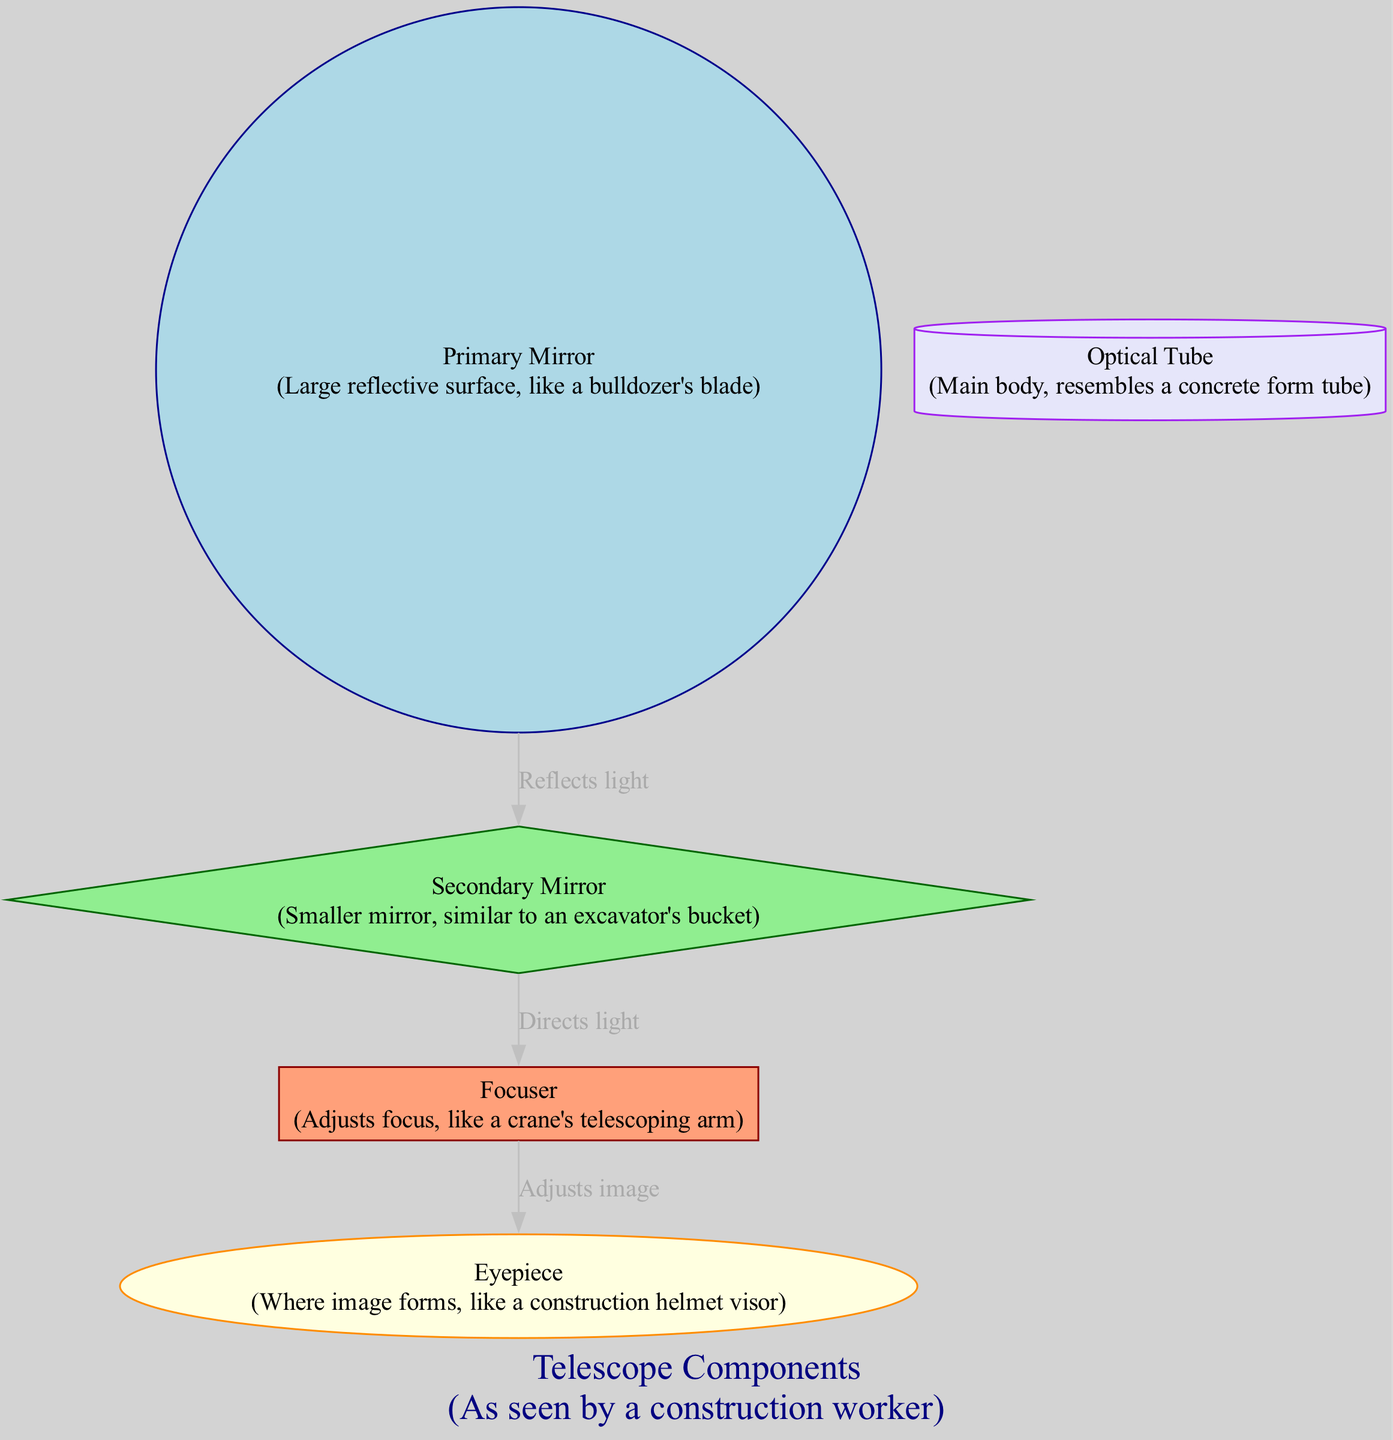What is the main reflective surface of the telescope? The diagram identifies the "Primary Mirror" as the large reflective surface, analogous to a bulldozer's blade. This is a labeled component that highlights its role and resemblance to construction equipment.
Answer: Primary Mirror How many components are shown in the diagram? By counting the nodes listed in the diagram, there are five identified components: Primary Mirror, Secondary Mirror, Focuser, Eyepiece, and Optical Tube. This count includes all distinct parts represented.
Answer: 5 What does the Secondary Mirror do? The Secondary Mirror reflects light towards the Focuser, as indicated by the connecting edge labeled "Directs light." This shows its functional role in the light path of the telescope.
Answer: Directs light What shapes are used for the Focuser and Eyepiece? The diagram specifies the shapes used for these components: the Focuser is a rectangle, and the Eyepiece is an oval. These descriptions of shape differentiate the components visually in the context of construction forms.
Answer: Rectangle, Oval Which component is responsible for adjusting the focus of the image? The Focuser is designated as the component that adjusts the focus, indicated clearly in the diagram's flow and described with its analogy to a crane's telescoping arm.
Answer: Focuser What is the connection between the Primary Mirror and Secondary Mirror? The edge connecting these two components is labeled "Reflects light," which indicates the directional function of light from the Primary Mirror to the Secondary Mirror, crucial in the light path of the telescope.
Answer: Reflects light How many edges are shown in the diagram? By counting the edges listed, there are three connections that illustrate the relationships and functions among the components, connecting how they interact in the telescope's operation.
Answer: 3 What does the Eyepiece represent in construction terms? The Eyepiece is compared to a construction helmet visor, emphasizing its role in forming the final image seen through the telescope, akin to how a visor protects and provides a view for a worker.
Answer: Construction helmet visor Which component can be viewed as the main body of the telescope? The Optical Tube serves as the main body of the telescope, likened to a concrete form tube. This description helps visualize its role as the foundational structure for the internal components.
Answer: Optical Tube 